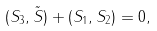<formula> <loc_0><loc_0><loc_500><loc_500>( S _ { 3 } , \tilde { S } ) + ( S _ { 1 } , S _ { 2 } ) = 0 ,</formula> 